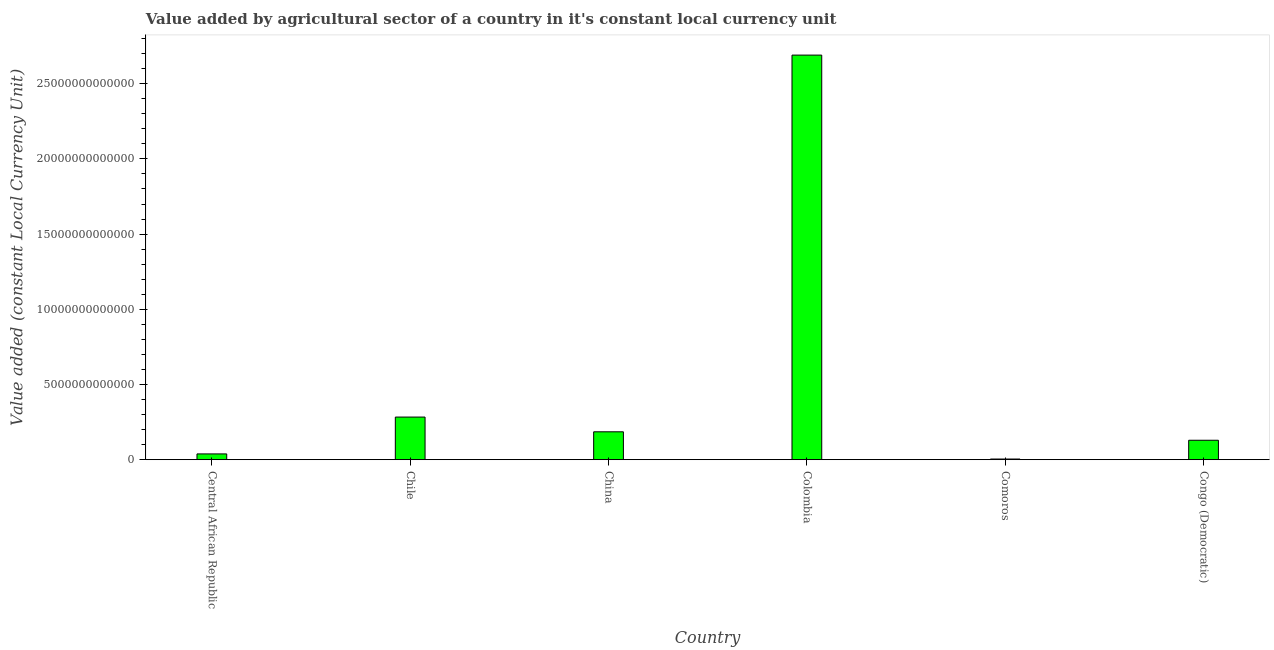What is the title of the graph?
Offer a very short reply. Value added by agricultural sector of a country in it's constant local currency unit. What is the label or title of the Y-axis?
Give a very brief answer. Value added (constant Local Currency Unit). What is the value added by agriculture sector in China?
Keep it short and to the point. 1.85e+12. Across all countries, what is the maximum value added by agriculture sector?
Ensure brevity in your answer.  2.69e+13. Across all countries, what is the minimum value added by agriculture sector?
Ensure brevity in your answer.  4.50e+1. In which country was the value added by agriculture sector minimum?
Your answer should be very brief. Comoros. What is the sum of the value added by agriculture sector?
Provide a succinct answer. 3.33e+13. What is the difference between the value added by agriculture sector in Chile and Colombia?
Provide a short and direct response. -2.41e+13. What is the average value added by agriculture sector per country?
Offer a terse response. 5.55e+12. What is the median value added by agriculture sector?
Offer a very short reply. 1.57e+12. In how many countries, is the value added by agriculture sector greater than 24000000000000 LCU?
Your response must be concise. 1. What is the ratio of the value added by agriculture sector in Chile to that in Congo (Democratic)?
Make the answer very short. 2.19. Is the value added by agriculture sector in Chile less than that in Colombia?
Keep it short and to the point. Yes. Is the difference between the value added by agriculture sector in Chile and China greater than the difference between any two countries?
Your answer should be very brief. No. What is the difference between the highest and the second highest value added by agriculture sector?
Give a very brief answer. 2.41e+13. Is the sum of the value added by agriculture sector in Central African Republic and Comoros greater than the maximum value added by agriculture sector across all countries?
Offer a terse response. No. What is the difference between the highest and the lowest value added by agriculture sector?
Your answer should be compact. 2.69e+13. Are all the bars in the graph horizontal?
Offer a very short reply. No. What is the difference between two consecutive major ticks on the Y-axis?
Make the answer very short. 5.00e+12. What is the Value added (constant Local Currency Unit) in Central African Republic?
Give a very brief answer. 3.84e+11. What is the Value added (constant Local Currency Unit) in Chile?
Make the answer very short. 2.83e+12. What is the Value added (constant Local Currency Unit) in China?
Your response must be concise. 1.85e+12. What is the Value added (constant Local Currency Unit) in Colombia?
Keep it short and to the point. 2.69e+13. What is the Value added (constant Local Currency Unit) in Comoros?
Give a very brief answer. 4.50e+1. What is the Value added (constant Local Currency Unit) of Congo (Democratic)?
Your answer should be very brief. 1.29e+12. What is the difference between the Value added (constant Local Currency Unit) in Central African Republic and Chile?
Your answer should be compact. -2.45e+12. What is the difference between the Value added (constant Local Currency Unit) in Central African Republic and China?
Provide a short and direct response. -1.47e+12. What is the difference between the Value added (constant Local Currency Unit) in Central African Republic and Colombia?
Your answer should be very brief. -2.65e+13. What is the difference between the Value added (constant Local Currency Unit) in Central African Republic and Comoros?
Ensure brevity in your answer.  3.39e+11. What is the difference between the Value added (constant Local Currency Unit) in Central African Republic and Congo (Democratic)?
Provide a succinct answer. -9.08e+11. What is the difference between the Value added (constant Local Currency Unit) in Chile and China?
Your answer should be compact. 9.80e+11. What is the difference between the Value added (constant Local Currency Unit) in Chile and Colombia?
Provide a short and direct response. -2.41e+13. What is the difference between the Value added (constant Local Currency Unit) in Chile and Comoros?
Provide a succinct answer. 2.79e+12. What is the difference between the Value added (constant Local Currency Unit) in Chile and Congo (Democratic)?
Make the answer very short. 1.54e+12. What is the difference between the Value added (constant Local Currency Unit) in China and Colombia?
Your answer should be very brief. -2.50e+13. What is the difference between the Value added (constant Local Currency Unit) in China and Comoros?
Provide a short and direct response. 1.81e+12. What is the difference between the Value added (constant Local Currency Unit) in China and Congo (Democratic)?
Provide a succinct answer. 5.62e+11. What is the difference between the Value added (constant Local Currency Unit) in Colombia and Comoros?
Offer a terse response. 2.69e+13. What is the difference between the Value added (constant Local Currency Unit) in Colombia and Congo (Democratic)?
Your response must be concise. 2.56e+13. What is the difference between the Value added (constant Local Currency Unit) in Comoros and Congo (Democratic)?
Offer a very short reply. -1.25e+12. What is the ratio of the Value added (constant Local Currency Unit) in Central African Republic to that in Chile?
Ensure brevity in your answer.  0.14. What is the ratio of the Value added (constant Local Currency Unit) in Central African Republic to that in China?
Make the answer very short. 0.21. What is the ratio of the Value added (constant Local Currency Unit) in Central African Republic to that in Colombia?
Your answer should be compact. 0.01. What is the ratio of the Value added (constant Local Currency Unit) in Central African Republic to that in Comoros?
Provide a succinct answer. 8.54. What is the ratio of the Value added (constant Local Currency Unit) in Central African Republic to that in Congo (Democratic)?
Keep it short and to the point. 0.3. What is the ratio of the Value added (constant Local Currency Unit) in Chile to that in China?
Give a very brief answer. 1.53. What is the ratio of the Value added (constant Local Currency Unit) in Chile to that in Colombia?
Provide a succinct answer. 0.1. What is the ratio of the Value added (constant Local Currency Unit) in Chile to that in Comoros?
Your answer should be compact. 63.01. What is the ratio of the Value added (constant Local Currency Unit) in Chile to that in Congo (Democratic)?
Ensure brevity in your answer.  2.19. What is the ratio of the Value added (constant Local Currency Unit) in China to that in Colombia?
Give a very brief answer. 0.07. What is the ratio of the Value added (constant Local Currency Unit) in China to that in Comoros?
Keep it short and to the point. 41.23. What is the ratio of the Value added (constant Local Currency Unit) in China to that in Congo (Democratic)?
Give a very brief answer. 1.44. What is the ratio of the Value added (constant Local Currency Unit) in Colombia to that in Comoros?
Your answer should be compact. 597.96. What is the ratio of the Value added (constant Local Currency Unit) in Colombia to that in Congo (Democratic)?
Ensure brevity in your answer.  20.81. What is the ratio of the Value added (constant Local Currency Unit) in Comoros to that in Congo (Democratic)?
Provide a short and direct response. 0.04. 